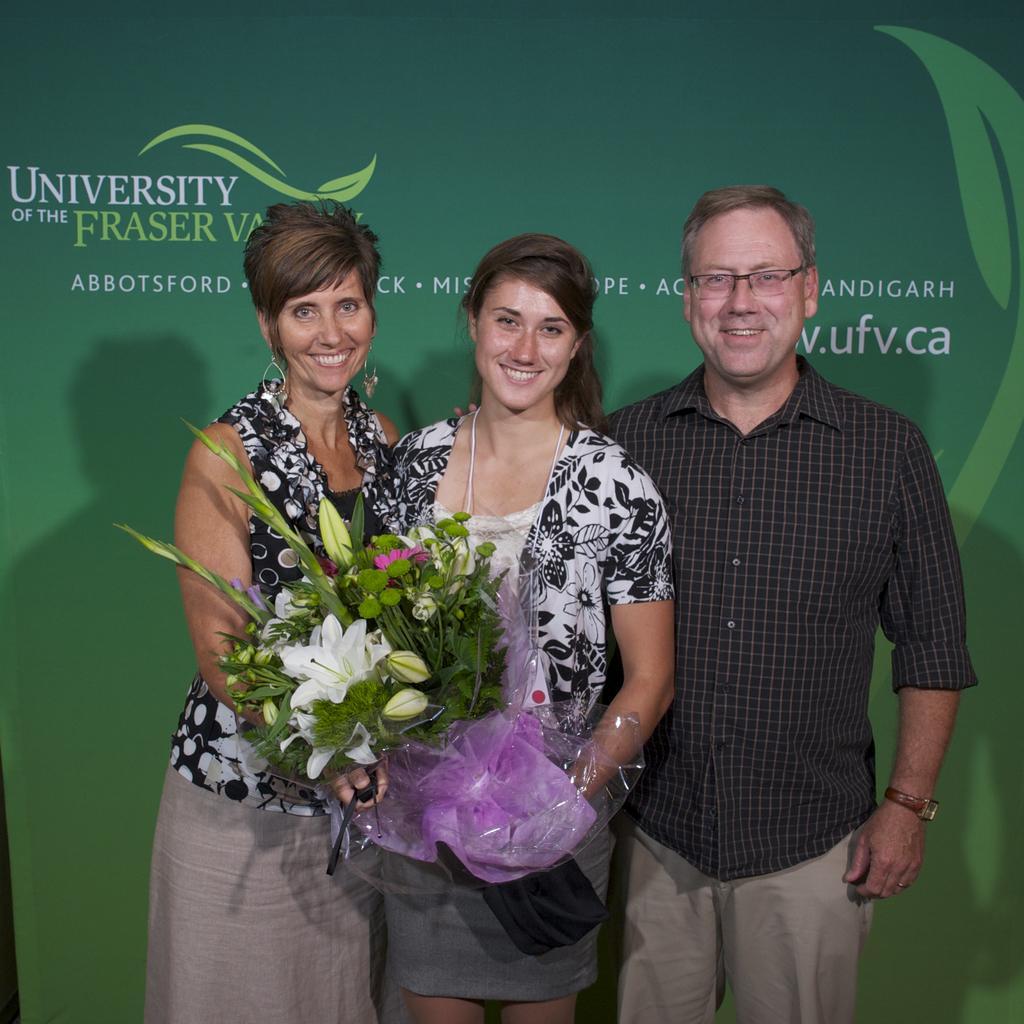Describe this image in one or two sentences. In this picture we can see three people standing and smiling were two women are holding a flower bouquet with their hands and in the background we can see a banner. 